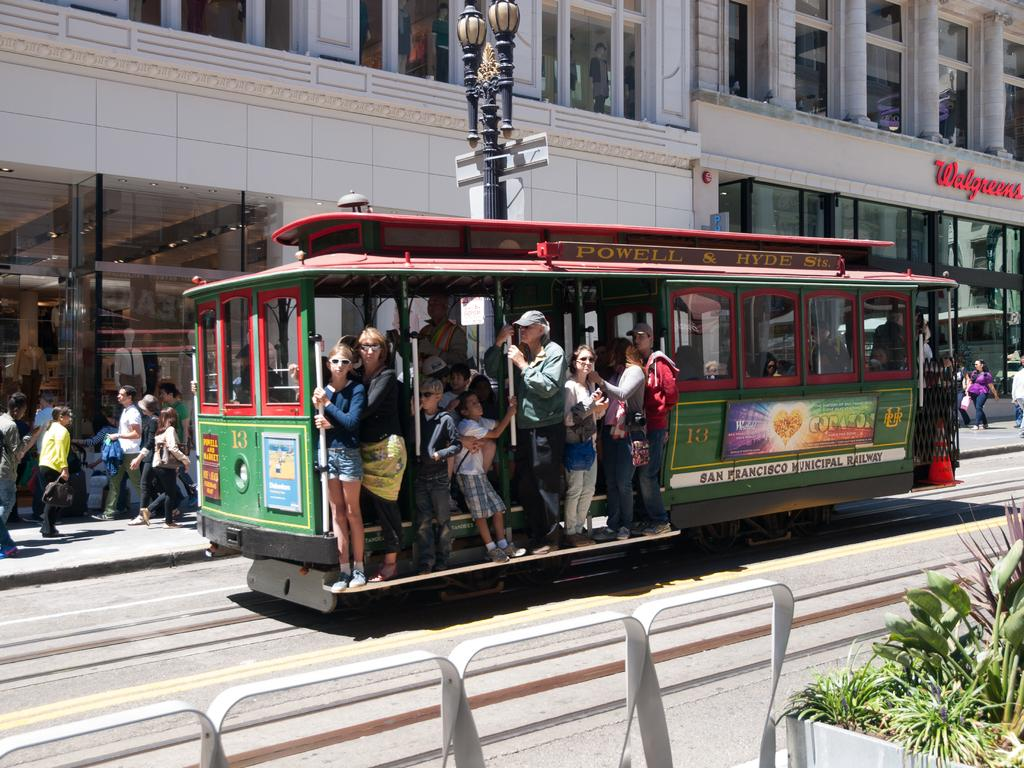<image>
Write a terse but informative summary of the picture. A San Francisco Municipal cable car is shown with several passengers; behind, and to the right is a Walgreens store. 